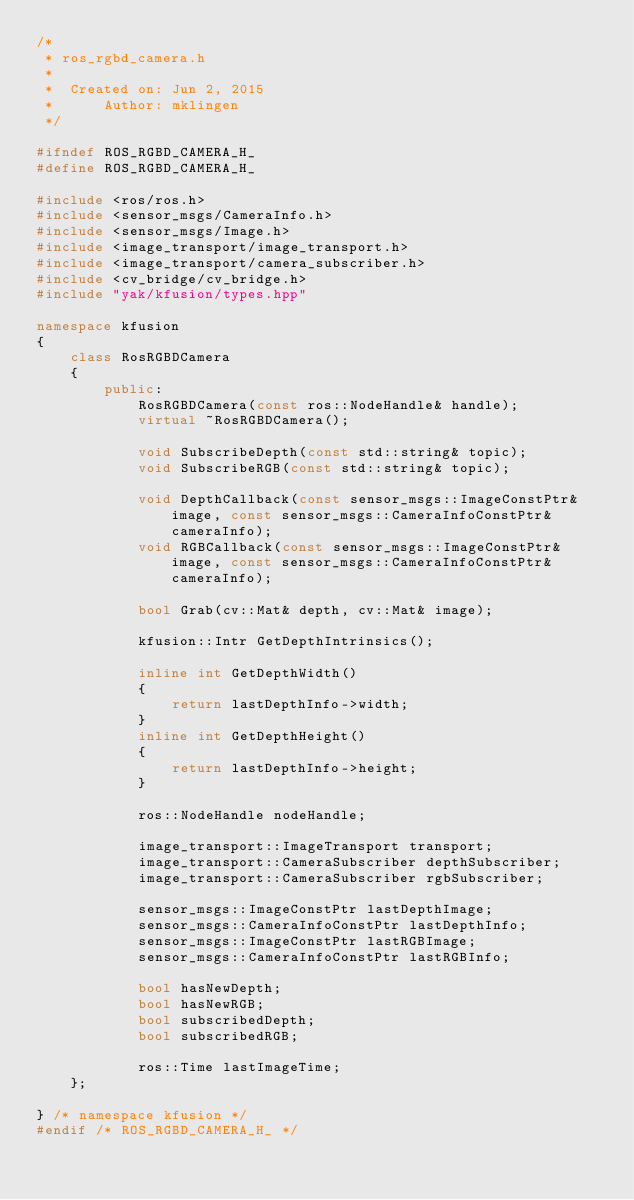<code> <loc_0><loc_0><loc_500><loc_500><_C++_>/*
 * ros_rgbd_camera.h
 *
 *  Created on: Jun 2, 2015
 *      Author: mklingen
 */

#ifndef ROS_RGBD_CAMERA_H_
#define ROS_RGBD_CAMERA_H_

#include <ros/ros.h>
#include <sensor_msgs/CameraInfo.h>
#include <sensor_msgs/Image.h>
#include <image_transport/image_transport.h>
#include <image_transport/camera_subscriber.h>
#include <cv_bridge/cv_bridge.h>
#include "yak/kfusion/types.hpp"

namespace kfusion
{
    class RosRGBDCamera
    {
        public:
            RosRGBDCamera(const ros::NodeHandle& handle);
            virtual ~RosRGBDCamera();

            void SubscribeDepth(const std::string& topic);
            void SubscribeRGB(const std::string& topic);

            void DepthCallback(const sensor_msgs::ImageConstPtr& image, const sensor_msgs::CameraInfoConstPtr& cameraInfo);
            void RGBCallback(const sensor_msgs::ImageConstPtr& image, const sensor_msgs::CameraInfoConstPtr& cameraInfo);

            bool Grab(cv::Mat& depth, cv::Mat& image);

            kfusion::Intr GetDepthIntrinsics();

            inline int GetDepthWidth()
            {
                return lastDepthInfo->width;
            }
            inline int GetDepthHeight()
            {
                return lastDepthInfo->height;
            }

            ros::NodeHandle nodeHandle;

            image_transport::ImageTransport transport;
            image_transport::CameraSubscriber depthSubscriber;
            image_transport::CameraSubscriber rgbSubscriber;

            sensor_msgs::ImageConstPtr lastDepthImage;
            sensor_msgs::CameraInfoConstPtr lastDepthInfo;
            sensor_msgs::ImageConstPtr lastRGBImage;
            sensor_msgs::CameraInfoConstPtr lastRGBInfo;

            bool hasNewDepth;
            bool hasNewRGB;
            bool subscribedDepth;
            bool subscribedRGB;

            ros::Time lastImageTime;
    };

} /* namespace kfusion */
#endif /* ROS_RGBD_CAMERA_H_ */
</code> 